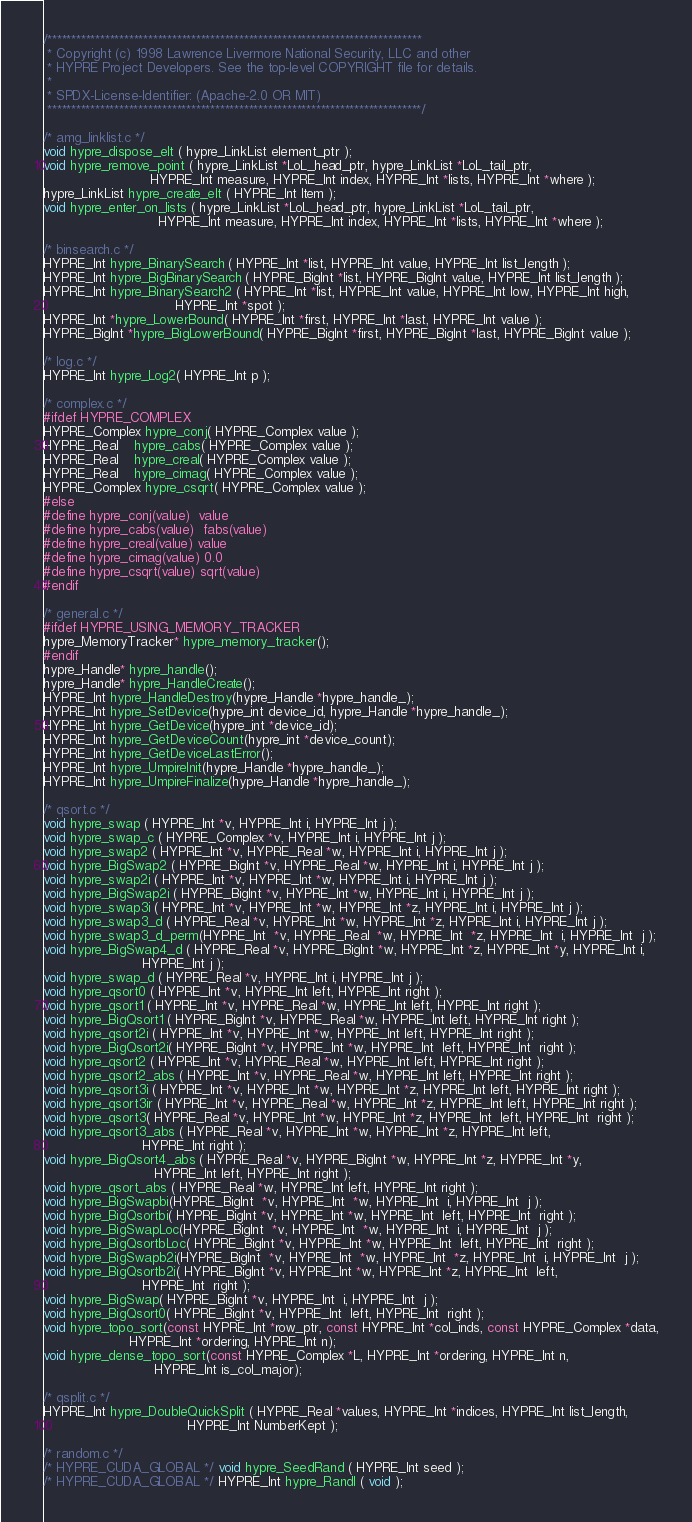<code> <loc_0><loc_0><loc_500><loc_500><_C_>/******************************************************************************
 * Copyright (c) 1998 Lawrence Livermore National Security, LLC and other
 * HYPRE Project Developers. See the top-level COPYRIGHT file for details.
 *
 * SPDX-License-Identifier: (Apache-2.0 OR MIT)
 ******************************************************************************/

/* amg_linklist.c */
void hypre_dispose_elt ( hypre_LinkList element_ptr );
void hypre_remove_point ( hypre_LinkList *LoL_head_ptr, hypre_LinkList *LoL_tail_ptr,
                          HYPRE_Int measure, HYPRE_Int index, HYPRE_Int *lists, HYPRE_Int *where );
hypre_LinkList hypre_create_elt ( HYPRE_Int Item );
void hypre_enter_on_lists ( hypre_LinkList *LoL_head_ptr, hypre_LinkList *LoL_tail_ptr,
                            HYPRE_Int measure, HYPRE_Int index, HYPRE_Int *lists, HYPRE_Int *where );

/* binsearch.c */
HYPRE_Int hypre_BinarySearch ( HYPRE_Int *list, HYPRE_Int value, HYPRE_Int list_length );
HYPRE_Int hypre_BigBinarySearch ( HYPRE_BigInt *list, HYPRE_BigInt value, HYPRE_Int list_length );
HYPRE_Int hypre_BinarySearch2 ( HYPRE_Int *list, HYPRE_Int value, HYPRE_Int low, HYPRE_Int high,
                                HYPRE_Int *spot );
HYPRE_Int *hypre_LowerBound( HYPRE_Int *first, HYPRE_Int *last, HYPRE_Int value );
HYPRE_BigInt *hypre_BigLowerBound( HYPRE_BigInt *first, HYPRE_BigInt *last, HYPRE_BigInt value );

/* log.c */
HYPRE_Int hypre_Log2( HYPRE_Int p );

/* complex.c */
#ifdef HYPRE_COMPLEX
HYPRE_Complex hypre_conj( HYPRE_Complex value );
HYPRE_Real    hypre_cabs( HYPRE_Complex value );
HYPRE_Real    hypre_creal( HYPRE_Complex value );
HYPRE_Real    hypre_cimag( HYPRE_Complex value );
HYPRE_Complex hypre_csqrt( HYPRE_Complex value );
#else
#define hypre_conj(value)  value
#define hypre_cabs(value)  fabs(value)
#define hypre_creal(value) value
#define hypre_cimag(value) 0.0
#define hypre_csqrt(value) sqrt(value)
#endif

/* general.c */
#ifdef HYPRE_USING_MEMORY_TRACKER
hypre_MemoryTracker* hypre_memory_tracker();
#endif
hypre_Handle* hypre_handle();
hypre_Handle* hypre_HandleCreate();
HYPRE_Int hypre_HandleDestroy(hypre_Handle *hypre_handle_);
HYPRE_Int hypre_SetDevice(hypre_int device_id, hypre_Handle *hypre_handle_);
HYPRE_Int hypre_GetDevice(hypre_int *device_id);
HYPRE_Int hypre_GetDeviceCount(hypre_int *device_count);
HYPRE_Int hypre_GetDeviceLastError();
HYPRE_Int hypre_UmpireInit(hypre_Handle *hypre_handle_);
HYPRE_Int hypre_UmpireFinalize(hypre_Handle *hypre_handle_);

/* qsort.c */
void hypre_swap ( HYPRE_Int *v, HYPRE_Int i, HYPRE_Int j );
void hypre_swap_c ( HYPRE_Complex *v, HYPRE_Int i, HYPRE_Int j );
void hypre_swap2 ( HYPRE_Int *v, HYPRE_Real *w, HYPRE_Int i, HYPRE_Int j );
void hypre_BigSwap2 ( HYPRE_BigInt *v, HYPRE_Real *w, HYPRE_Int i, HYPRE_Int j );
void hypre_swap2i ( HYPRE_Int *v, HYPRE_Int *w, HYPRE_Int i, HYPRE_Int j );
void hypre_BigSwap2i ( HYPRE_BigInt *v, HYPRE_Int *w, HYPRE_Int i, HYPRE_Int j );
void hypre_swap3i ( HYPRE_Int *v, HYPRE_Int *w, HYPRE_Int *z, HYPRE_Int i, HYPRE_Int j );
void hypre_swap3_d ( HYPRE_Real *v, HYPRE_Int *w, HYPRE_Int *z, HYPRE_Int i, HYPRE_Int j );
void hypre_swap3_d_perm(HYPRE_Int  *v, HYPRE_Real  *w, HYPRE_Int  *z, HYPRE_Int  i, HYPRE_Int  j );
void hypre_BigSwap4_d ( HYPRE_Real *v, HYPRE_BigInt *w, HYPRE_Int *z, HYPRE_Int *y, HYPRE_Int i,
                        HYPRE_Int j );
void hypre_swap_d ( HYPRE_Real *v, HYPRE_Int i, HYPRE_Int j );
void hypre_qsort0 ( HYPRE_Int *v, HYPRE_Int left, HYPRE_Int right );
void hypre_qsort1 ( HYPRE_Int *v, HYPRE_Real *w, HYPRE_Int left, HYPRE_Int right );
void hypre_BigQsort1 ( HYPRE_BigInt *v, HYPRE_Real *w, HYPRE_Int left, HYPRE_Int right );
void hypre_qsort2i ( HYPRE_Int *v, HYPRE_Int *w, HYPRE_Int left, HYPRE_Int right );
void hypre_BigQsort2i( HYPRE_BigInt *v, HYPRE_Int *w, HYPRE_Int  left, HYPRE_Int  right );
void hypre_qsort2 ( HYPRE_Int *v, HYPRE_Real *w, HYPRE_Int left, HYPRE_Int right );
void hypre_qsort2_abs ( HYPRE_Int *v, HYPRE_Real *w, HYPRE_Int left, HYPRE_Int right );
void hypre_qsort3i ( HYPRE_Int *v, HYPRE_Int *w, HYPRE_Int *z, HYPRE_Int left, HYPRE_Int right );
void hypre_qsort3ir ( HYPRE_Int *v, HYPRE_Real *w, HYPRE_Int *z, HYPRE_Int left, HYPRE_Int right );
void hypre_qsort3( HYPRE_Real *v, HYPRE_Int *w, HYPRE_Int *z, HYPRE_Int  left, HYPRE_Int  right );
void hypre_qsort3_abs ( HYPRE_Real *v, HYPRE_Int *w, HYPRE_Int *z, HYPRE_Int left,
                        HYPRE_Int right );
void hypre_BigQsort4_abs ( HYPRE_Real *v, HYPRE_BigInt *w, HYPRE_Int *z, HYPRE_Int *y,
                           HYPRE_Int left, HYPRE_Int right );
void hypre_qsort_abs ( HYPRE_Real *w, HYPRE_Int left, HYPRE_Int right );
void hypre_BigSwapbi(HYPRE_BigInt  *v, HYPRE_Int  *w, HYPRE_Int  i, HYPRE_Int  j );
void hypre_BigQsortbi( HYPRE_BigInt *v, HYPRE_Int *w, HYPRE_Int  left, HYPRE_Int  right );
void hypre_BigSwapLoc(HYPRE_BigInt  *v, HYPRE_Int  *w, HYPRE_Int  i, HYPRE_Int  j );
void hypre_BigQsortbLoc( HYPRE_BigInt *v, HYPRE_Int *w, HYPRE_Int  left, HYPRE_Int  right );
void hypre_BigSwapb2i(HYPRE_BigInt  *v, HYPRE_Int  *w, HYPRE_Int  *z, HYPRE_Int  i, HYPRE_Int  j );
void hypre_BigQsortb2i( HYPRE_BigInt *v, HYPRE_Int *w, HYPRE_Int *z, HYPRE_Int  left,
                        HYPRE_Int  right );
void hypre_BigSwap( HYPRE_BigInt *v, HYPRE_Int  i, HYPRE_Int  j );
void hypre_BigQsort0( HYPRE_BigInt *v, HYPRE_Int  left, HYPRE_Int  right );
void hypre_topo_sort(const HYPRE_Int *row_ptr, const HYPRE_Int *col_inds, const HYPRE_Complex *data,
                     HYPRE_Int *ordering, HYPRE_Int n);
void hypre_dense_topo_sort(const HYPRE_Complex *L, HYPRE_Int *ordering, HYPRE_Int n,
                           HYPRE_Int is_col_major);

/* qsplit.c */
HYPRE_Int hypre_DoubleQuickSplit ( HYPRE_Real *values, HYPRE_Int *indices, HYPRE_Int list_length,
                                   HYPRE_Int NumberKept );

/* random.c */
/* HYPRE_CUDA_GLOBAL */ void hypre_SeedRand ( HYPRE_Int seed );
/* HYPRE_CUDA_GLOBAL */ HYPRE_Int hypre_RandI ( void );</code> 